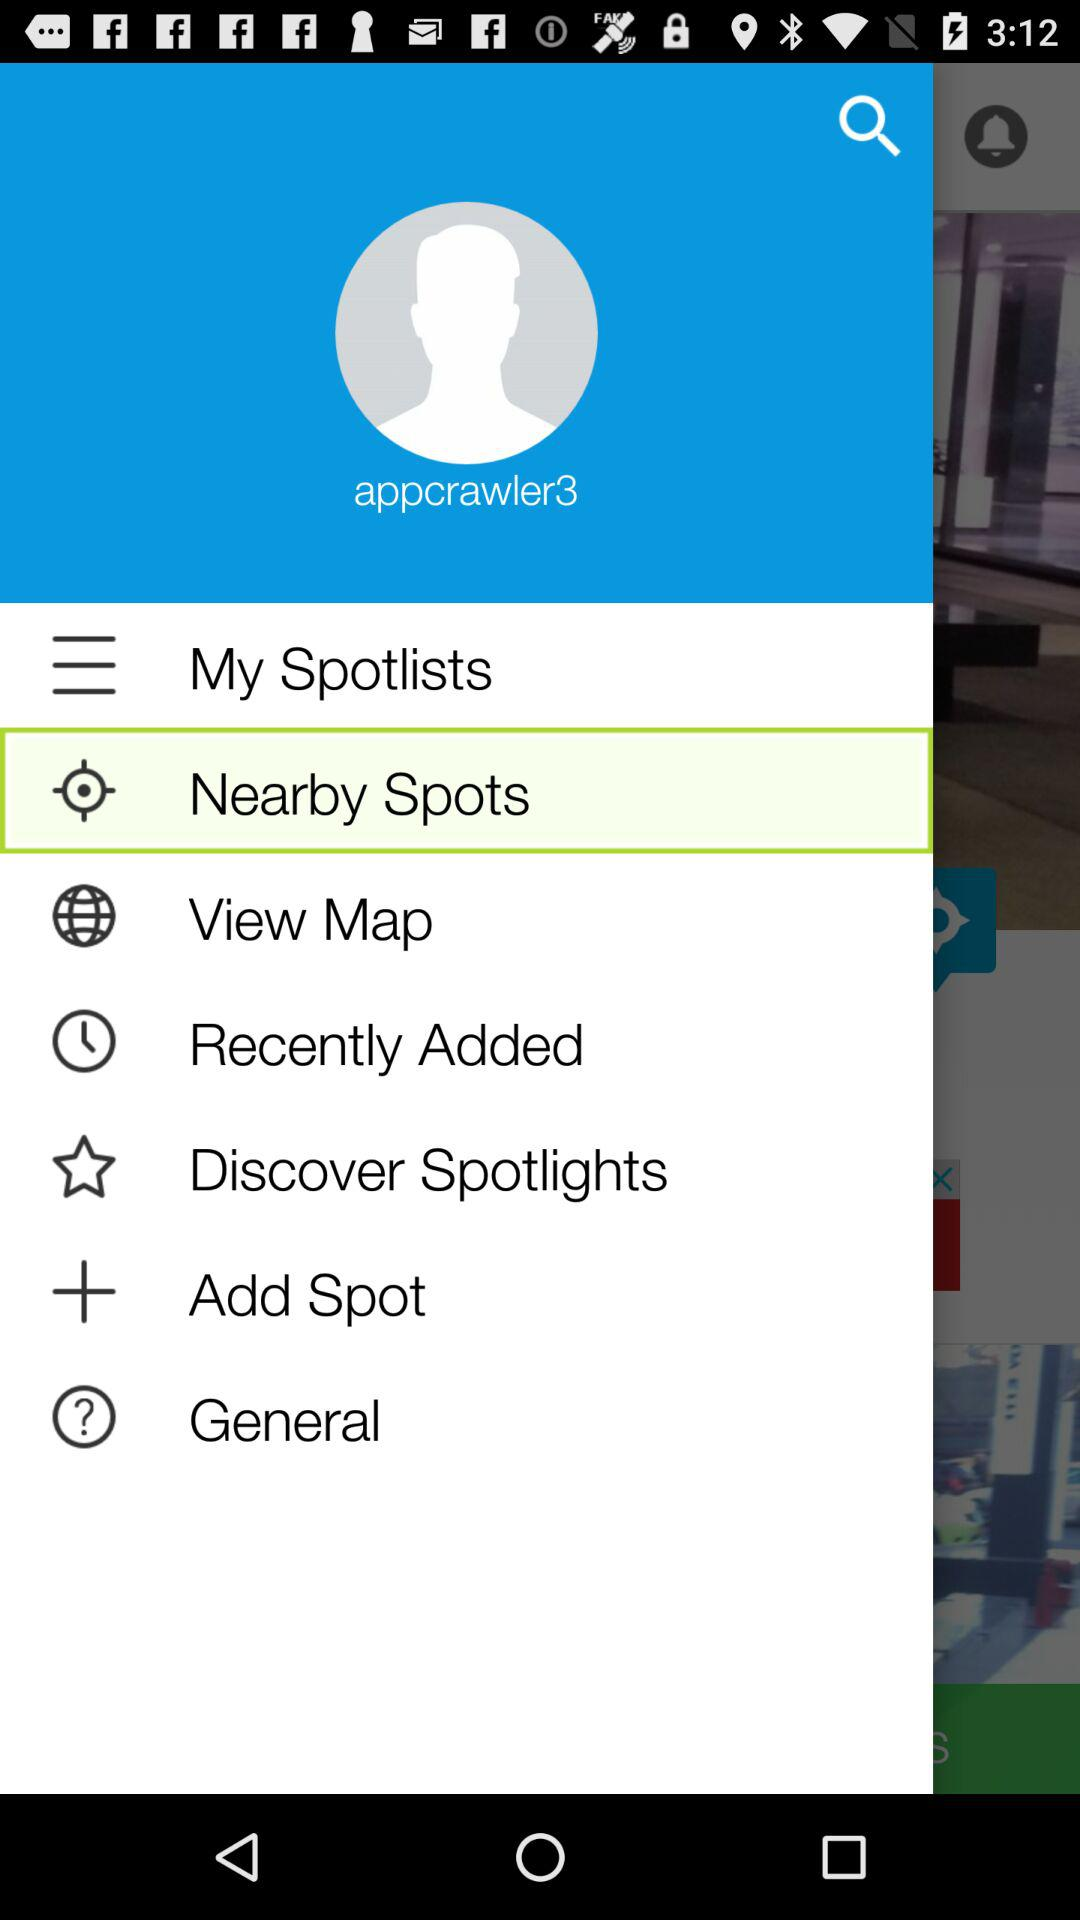Which item is highlighted? The highlighted item is "Nearby Spots". 